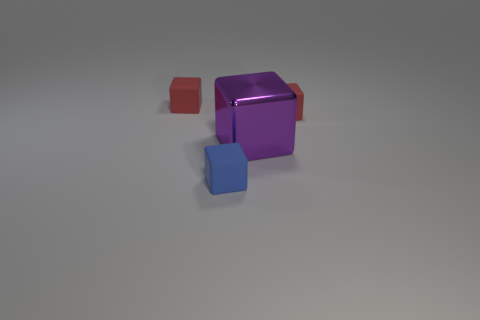Subtract all tiny matte cubes. How many cubes are left? 1 Subtract all purple cubes. How many cubes are left? 3 Add 2 tiny purple matte cylinders. How many objects exist? 6 Subtract 2 blocks. How many blocks are left? 2 Subtract all purple blocks. Subtract all yellow cylinders. How many blocks are left? 3 Subtract all red cylinders. How many blue blocks are left? 1 Subtract all purple metal cubes. Subtract all small blue rubber cubes. How many objects are left? 2 Add 4 purple metal blocks. How many purple metal blocks are left? 5 Add 1 large cubes. How many large cubes exist? 2 Subtract 0 purple balls. How many objects are left? 4 